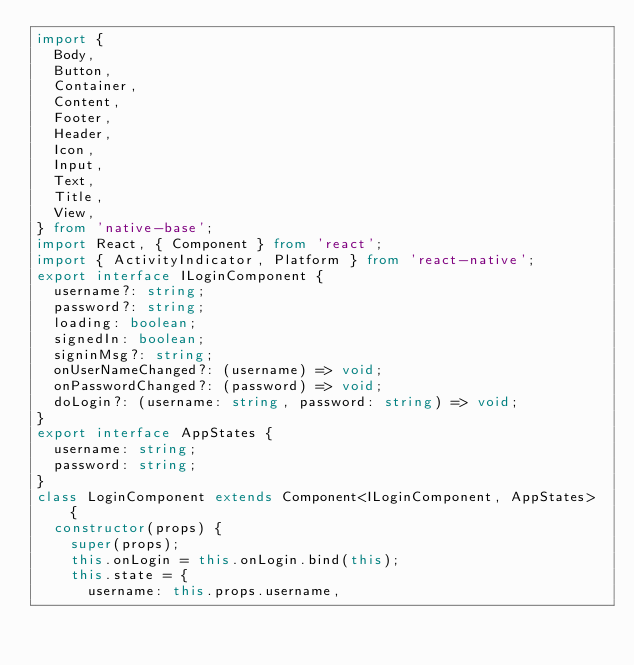Convert code to text. <code><loc_0><loc_0><loc_500><loc_500><_TypeScript_>import {
  Body,
  Button,
  Container,
  Content,
  Footer,
  Header,
  Icon,
  Input,
  Text,
  Title,
  View,
} from 'native-base';
import React, { Component } from 'react';
import { ActivityIndicator, Platform } from 'react-native';
export interface ILoginComponent {
  username?: string;
  password?: string;
  loading: boolean;
  signedIn: boolean;
  signinMsg?: string;
  onUserNameChanged?: (username) => void;
  onPasswordChanged?: (password) => void;
  doLogin?: (username: string, password: string) => void;
}
export interface AppStates {
  username: string;
  password: string;
}
class LoginComponent extends Component<ILoginComponent, AppStates> {
  constructor(props) {
    super(props);
    this.onLogin = this.onLogin.bind(this);
    this.state = {
      username: this.props.username,</code> 